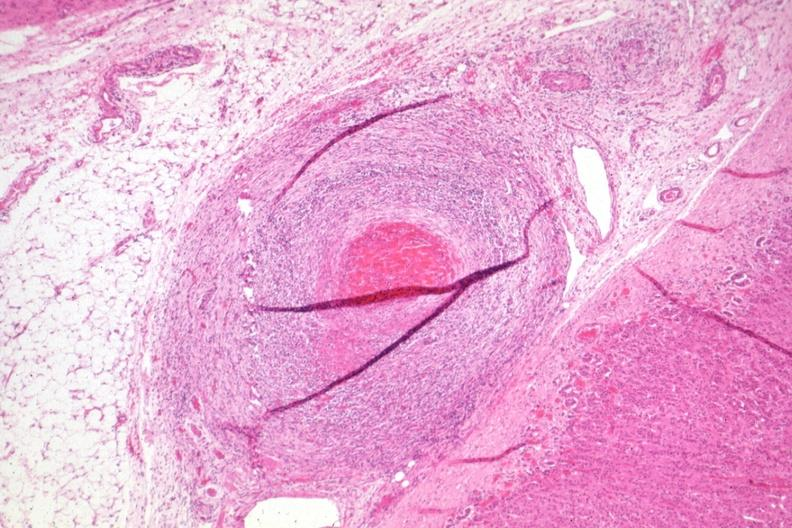s polyarteritis nodosa present?
Answer the question using a single word or phrase. Yes 